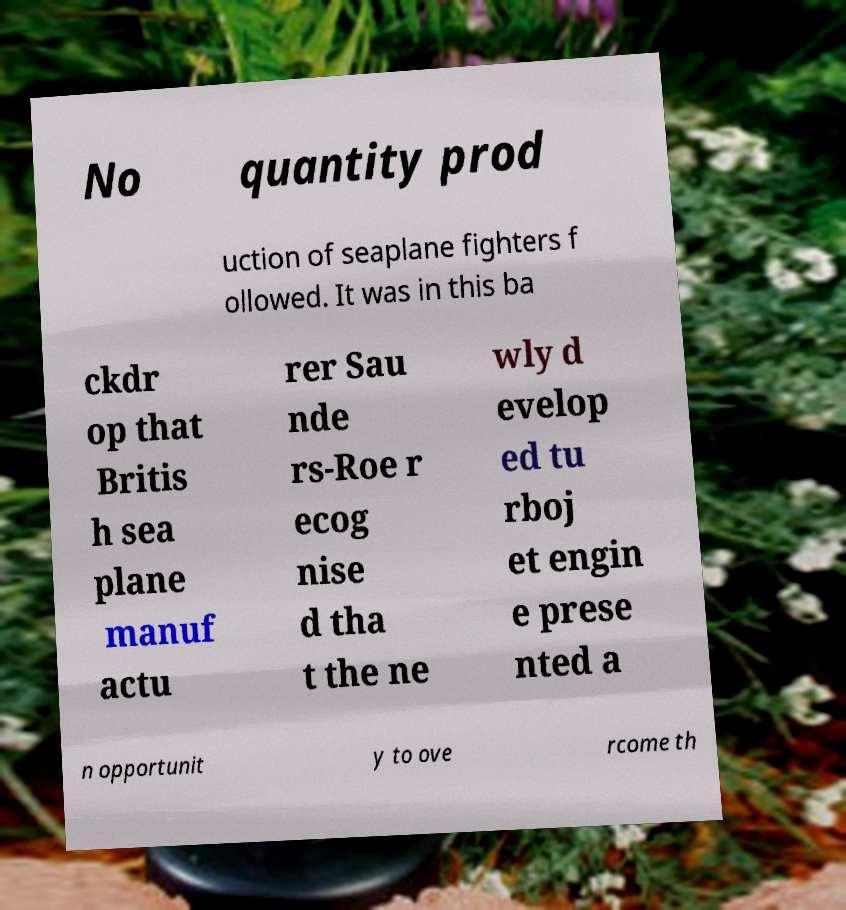What messages or text are displayed in this image? I need them in a readable, typed format. No quantity prod uction of seaplane fighters f ollowed. It was in this ba ckdr op that Britis h sea plane manuf actu rer Sau nde rs-Roe r ecog nise d tha t the ne wly d evelop ed tu rboj et engin e prese nted a n opportunit y to ove rcome th 